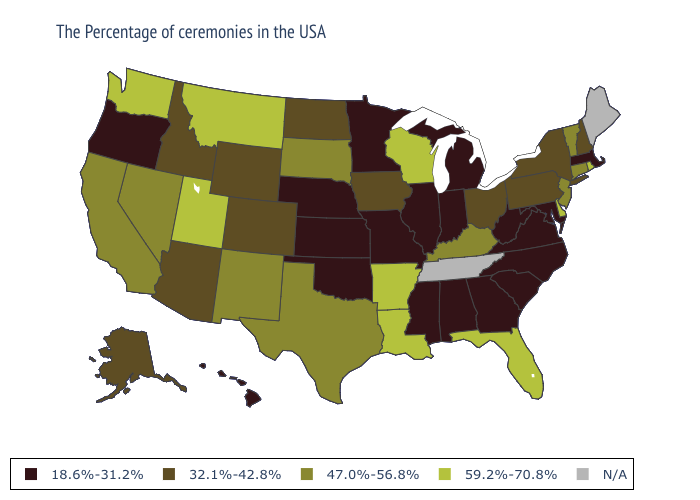Among the states that border New Mexico , which have the lowest value?
Quick response, please. Oklahoma. Among the states that border Montana , does South Dakota have the lowest value?
Keep it brief. No. Name the states that have a value in the range 47.0%-56.8%?
Quick response, please. Vermont, Connecticut, New Jersey, Kentucky, Texas, South Dakota, New Mexico, Nevada, California. What is the value of Ohio?
Answer briefly. 32.1%-42.8%. Name the states that have a value in the range 59.2%-70.8%?
Short answer required. Rhode Island, Delaware, Florida, Wisconsin, Louisiana, Arkansas, Utah, Montana, Washington. Does the first symbol in the legend represent the smallest category?
Write a very short answer. Yes. Is the legend a continuous bar?
Write a very short answer. No. Which states have the highest value in the USA?
Give a very brief answer. Rhode Island, Delaware, Florida, Wisconsin, Louisiana, Arkansas, Utah, Montana, Washington. What is the lowest value in the USA?
Quick response, please. 18.6%-31.2%. Name the states that have a value in the range 59.2%-70.8%?
Be succinct. Rhode Island, Delaware, Florida, Wisconsin, Louisiana, Arkansas, Utah, Montana, Washington. Among the states that border Georgia , which have the highest value?
Be succinct. Florida. What is the value of New Mexico?
Write a very short answer. 47.0%-56.8%. What is the value of Wisconsin?
Give a very brief answer. 59.2%-70.8%. What is the value of Michigan?
Quick response, please. 18.6%-31.2%. 